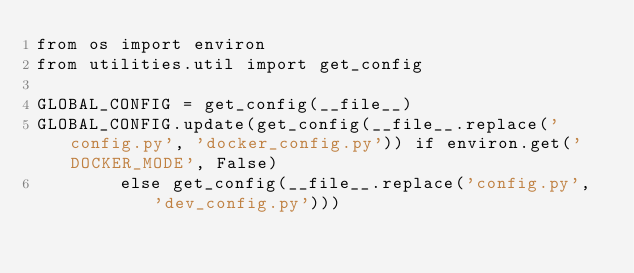Convert code to text. <code><loc_0><loc_0><loc_500><loc_500><_Python_>from os import environ
from utilities.util import get_config

GLOBAL_CONFIG = get_config(__file__)
GLOBAL_CONFIG.update(get_config(__file__.replace('config.py', 'docker_config.py')) if environ.get('DOCKER_MODE', False)
        else get_config(__file__.replace('config.py', 'dev_config.py')))
</code> 